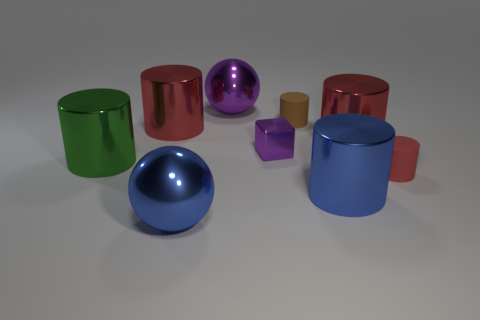Do the brown rubber object and the large purple object have the same shape? Although they are both spherical, the materials give them a different aesthetic. The brown object appears to have a matte finish typical of rubber, while the large purple object has a reflective surface, suggesting it is made of a different material, possibly a glossy plastic or metal. 